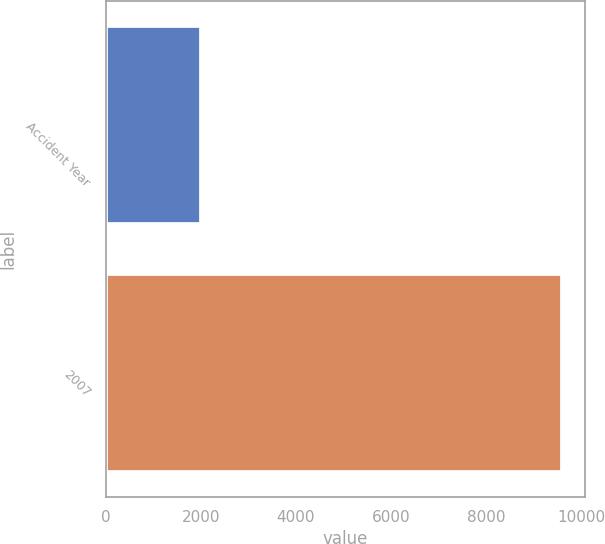Convert chart to OTSL. <chart><loc_0><loc_0><loc_500><loc_500><bar_chart><fcel>Accident Year<fcel>2007<nl><fcel>2008<fcel>9609<nl></chart> 